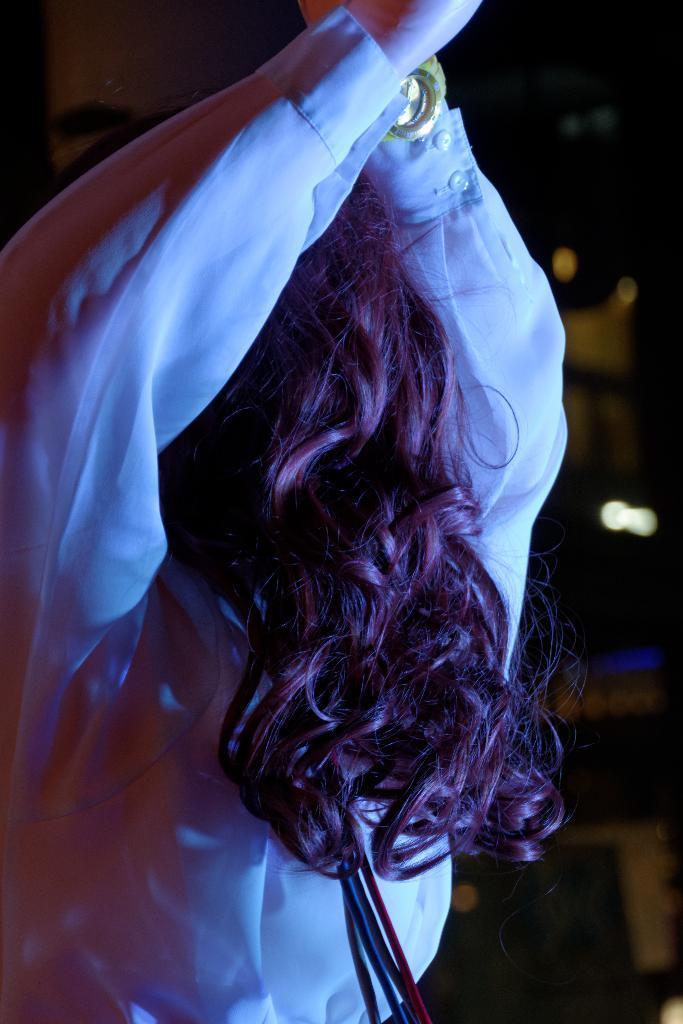Can you describe this image briefly? In this picture there is a person. In the background of the image it is blurry and dark. 